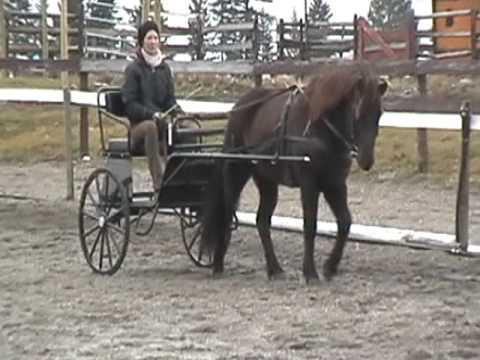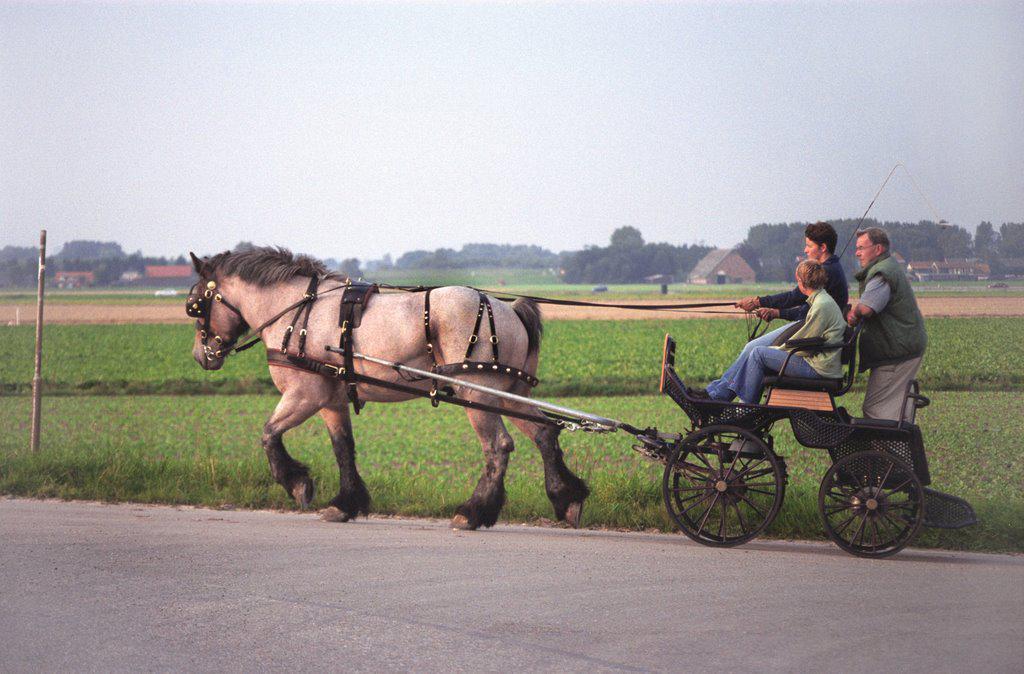The first image is the image on the left, the second image is the image on the right. Assess this claim about the two images: "At least one horse is black.". Correct or not? Answer yes or no. Yes. 